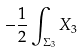<formula> <loc_0><loc_0><loc_500><loc_500>- { \frac { 1 } { 2 } } \int _ { \Sigma _ { 3 } } X _ { 3 }</formula> 